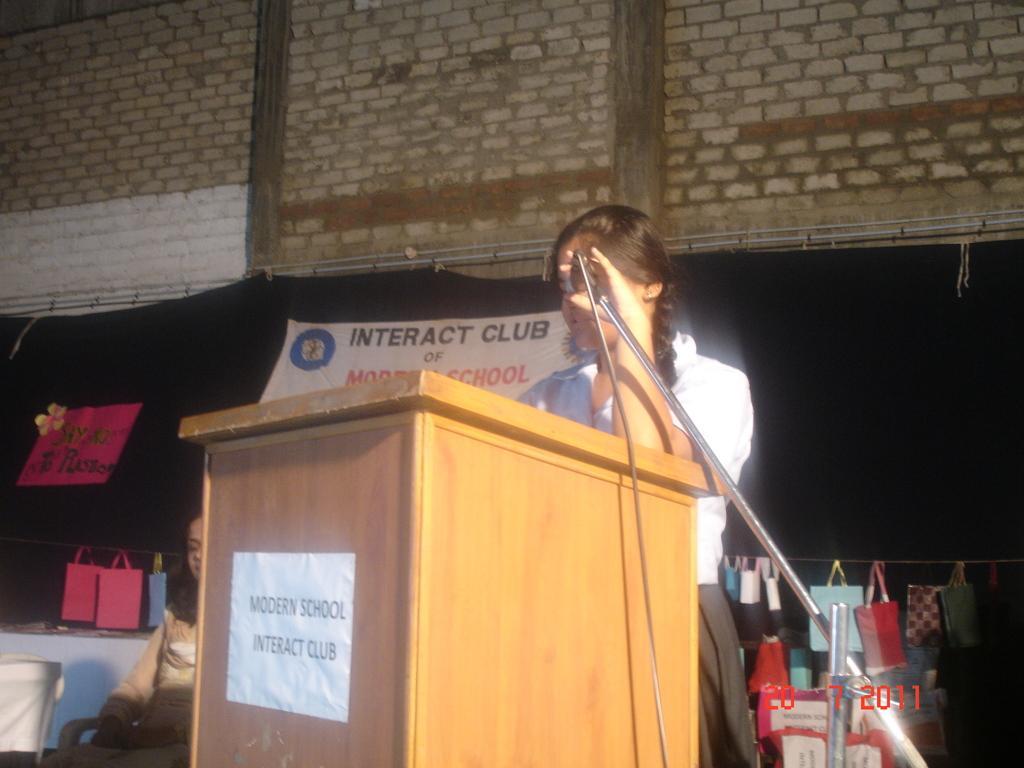Describe this image in one or two sentences. This picture is clicked in school. Girl in white shirt is standing near the podium and she is holding microphone in her hand. Behind her, we see woman sitting on chair and behind her, we see many bags hanged to the rope and behind that, we see a banner on which "Interact club" is written and on top of the picture, we see a wall which is made of bricks. 